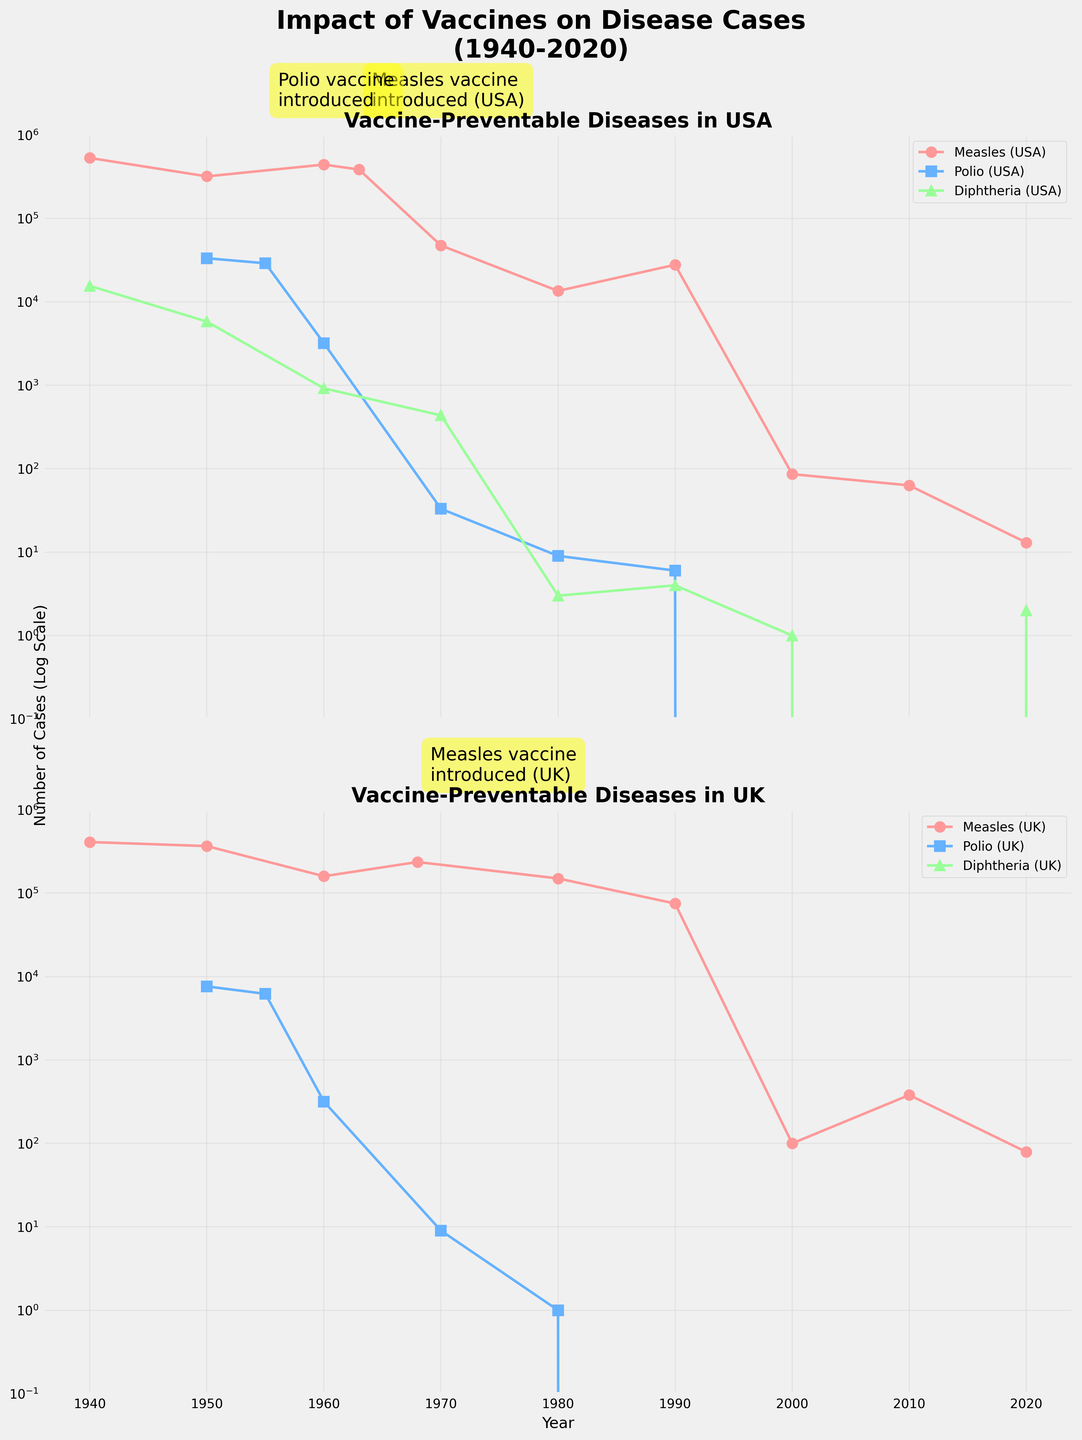Which disease had the most significant decrease in reported cases in the USA after the introduction of vaccines? To determine this, compare the number of cases before and after the introduction of vaccines for each disease in the USA. Measles shows a drop from 385,156 cases in 1963 to 13 cases in 2020, Polio from 33,000 in 1950 to 0 in 2020, and Diphtheria from 15,536 in 1940 to 2 in 2020. Polio shows the most significant decrease to zero cases.
Answer: Polio In what year was the Measles vaccine introduced in the USA, and how did the number of cases change in the subsequent decade? The Measles vaccine is annotated as being introduced in 1963 in the USA. Compare the number of cases in 1963 (385,156) to the number in 1970 (47,351). The cases significantly decreased over a decade.
Answer: 1963, decreased Which disease had the largest number of reported cases in the UK in 1940, and what was the next largest number of cases for that disease in a subsequent year? From the data, Measles had the largest number of reported cases in 1940 in the UK with 409,711 cases. The next largest was in 1950 with 366,344 cases.
Answer: Measles, 366,344 Compare the trend of Polio cases in the USA and UK after the vaccine introduction. Which country eliminated Polio cases first, and in what year? Examine the trend line for Polio in both countries after 1955, when the vaccine was introduced. The USA eliminated Polio cases first by 2000 (0 cases), while the UK also eliminated it by 2000 (0 cases). Though both eliminated in the same year, the USA's graph reaches 0 cases with no fluctuation.
Answer: USA, 2000 What does the logarithmic scale used in the plots imply about the rates of change in disease cases over time? A logarithmic scale implies exponential rates of change. A slight downward slope represents a significant reduction in number of cases. Examining both countries, the rapid and steep decline after vaccine introductions signifies exponential reductions in disease incidence.
Answer: Exponential reduction Which country experienced a faster and more consistent decline in Diphtheria cases, and how is it visually represented in the plot? Compare the trend lines for Diphtheria in both the USA and the UK. The USA shows a faster and more consistent decline, represented by the swift drop to very low (near zero) levels by 1980 without much fluctuation.
Answer: USA What impact did the Measles vaccine introduction in the UK have on cases by 1980? Compare the cases before the vaccine introduction in 1968 (236,154) and the cases by 1980 (150,000). There's a marked decrease, indicating a positive impact of the vaccine by reducing the number of cases.
Answer: Decrease Observe the trends for Measles in the UK. After an initial decrease post-vaccine introduction, does the data show any rise in subsequent years? After the initial decrease from 1968 (236,154 cases) to 1980 (150,000 cases), there is a further decrease observed until 2020 with a few fluctuations, mainly showing a steady decline. A slight increase appears in 2010 (380 cases).
Answer: Yes Which vaccine-preventable disease shows very low or negligible cases in both countries by 2020? Observing the final data points, Polio shows negligible cases in both the USA and the UK by 2020, consistently reaching 0 cases in both countries.
Answer: Polio 